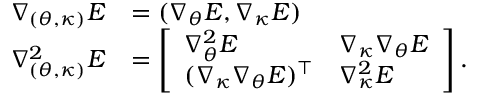Convert formula to latex. <formula><loc_0><loc_0><loc_500><loc_500>\begin{array} { r l } { \nabla _ { ( { \theta } , { \kappa } ) } E } & { = ( \nabla _ { \theta } E , \nabla _ { \kappa } E ) } \\ { \nabla _ { ( { \theta } , { \kappa } ) } ^ { 2 } E } & { = \left [ \begin{array} { l l } { \nabla _ { \theta } ^ { 2 } E } & { \nabla _ { \kappa } \nabla _ { \theta } E } \\ { ( \nabla _ { \kappa } \nabla _ { \theta } E ) ^ { \intercal } } & { \nabla _ { \kappa } ^ { 2 } E } \end{array} \right ] . } \end{array}</formula> 